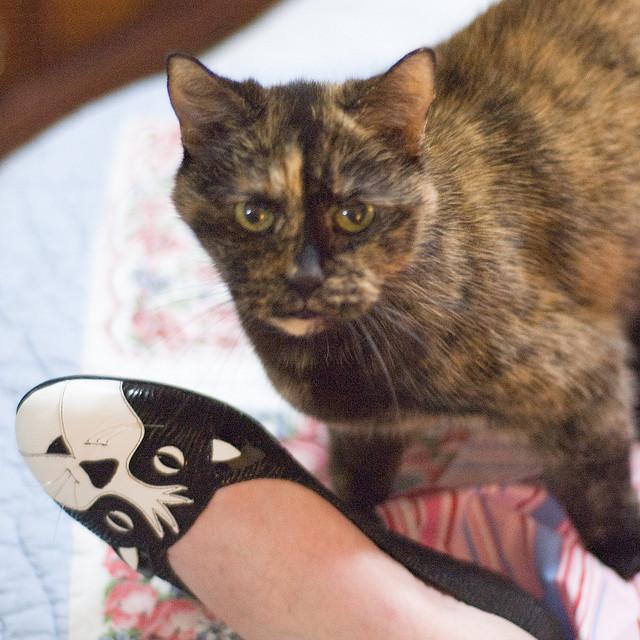What is one of the largest breeds of this animal?

Choices:
A) maine coon
B) greyhound
C) munchkin
D) doberman maine coon 